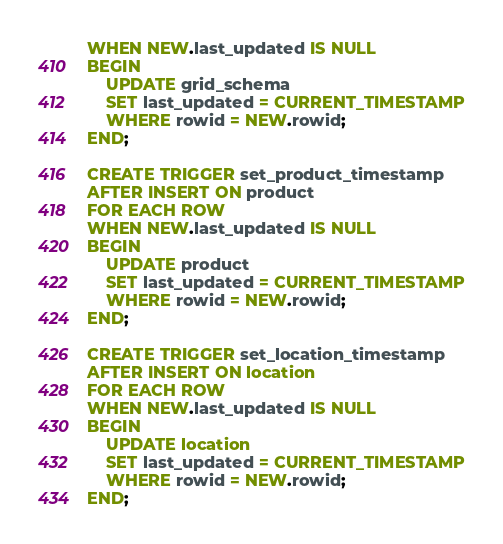<code> <loc_0><loc_0><loc_500><loc_500><_SQL_>WHEN NEW.last_updated IS NULL
BEGIN
    UPDATE grid_schema
    SET last_updated = CURRENT_TIMESTAMP
    WHERE rowid = NEW.rowid;
END;

CREATE TRIGGER set_product_timestamp
AFTER INSERT ON product
FOR EACH ROW
WHEN NEW.last_updated IS NULL
BEGIN
    UPDATE product
    SET last_updated = CURRENT_TIMESTAMP
    WHERE rowid = NEW.rowid;
END;

CREATE TRIGGER set_location_timestamp
AFTER INSERT ON location
FOR EACH ROW
WHEN NEW.last_updated IS NULL
BEGIN
    UPDATE location
    SET last_updated = CURRENT_TIMESTAMP
    WHERE rowid = NEW.rowid;
END;
</code> 